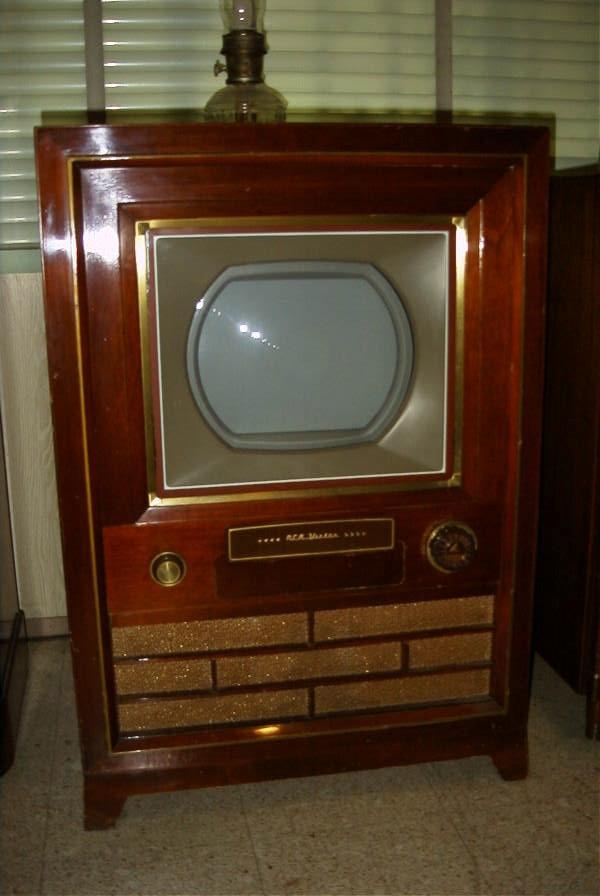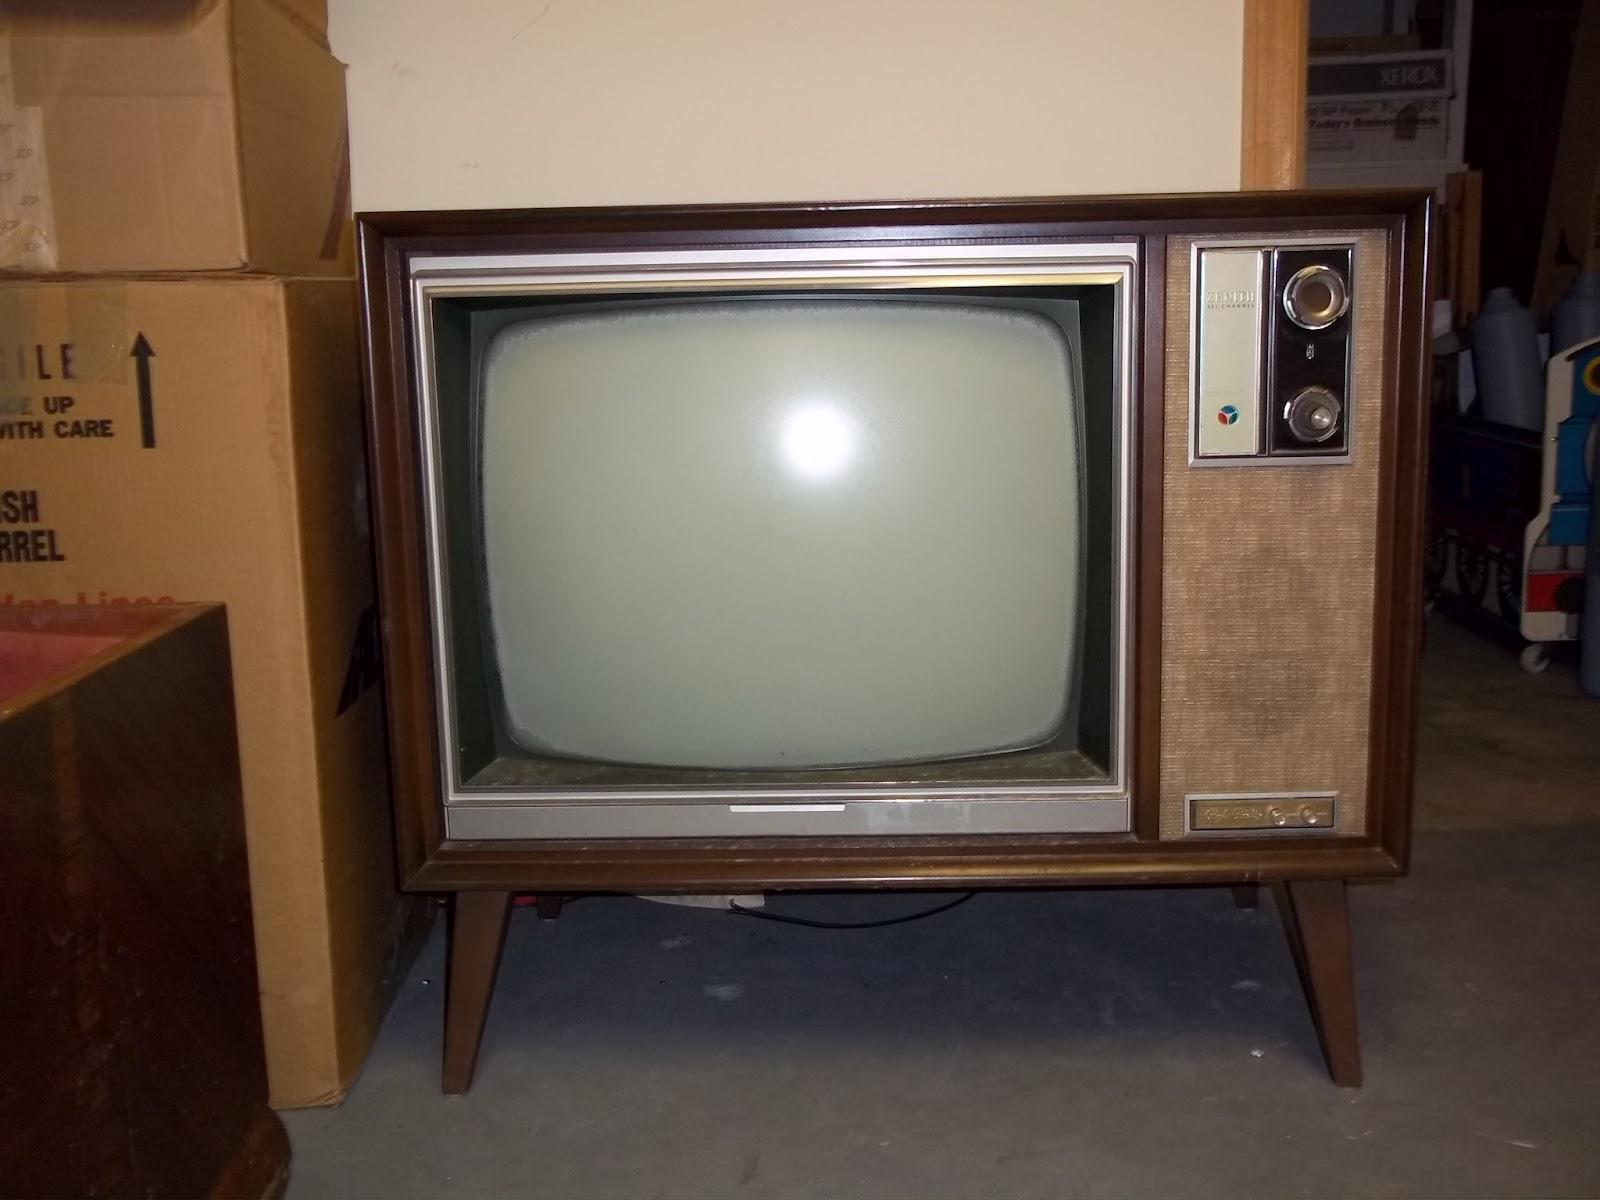The first image is the image on the left, the second image is the image on the right. Assess this claim about the two images: "Both TVs feature small non-square screens set in boxy wood consoles, and one has a picture playing on its screen, while the other has a rich cherry finish console.". Correct or not? Answer yes or no. No. The first image is the image on the left, the second image is the image on the right. For the images shown, is this caption "Two console televison cabinets in dark wood feature a picture tube in the upper section and speakers housed in the bottom section." true? Answer yes or no. No. 